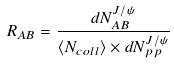Convert formula to latex. <formula><loc_0><loc_0><loc_500><loc_500>R _ { A B } = \frac { d N ^ { J / \psi } _ { A B } } { \langle N _ { c o l l } \rangle \times d N ^ { J / \psi } _ { p p } }</formula> 